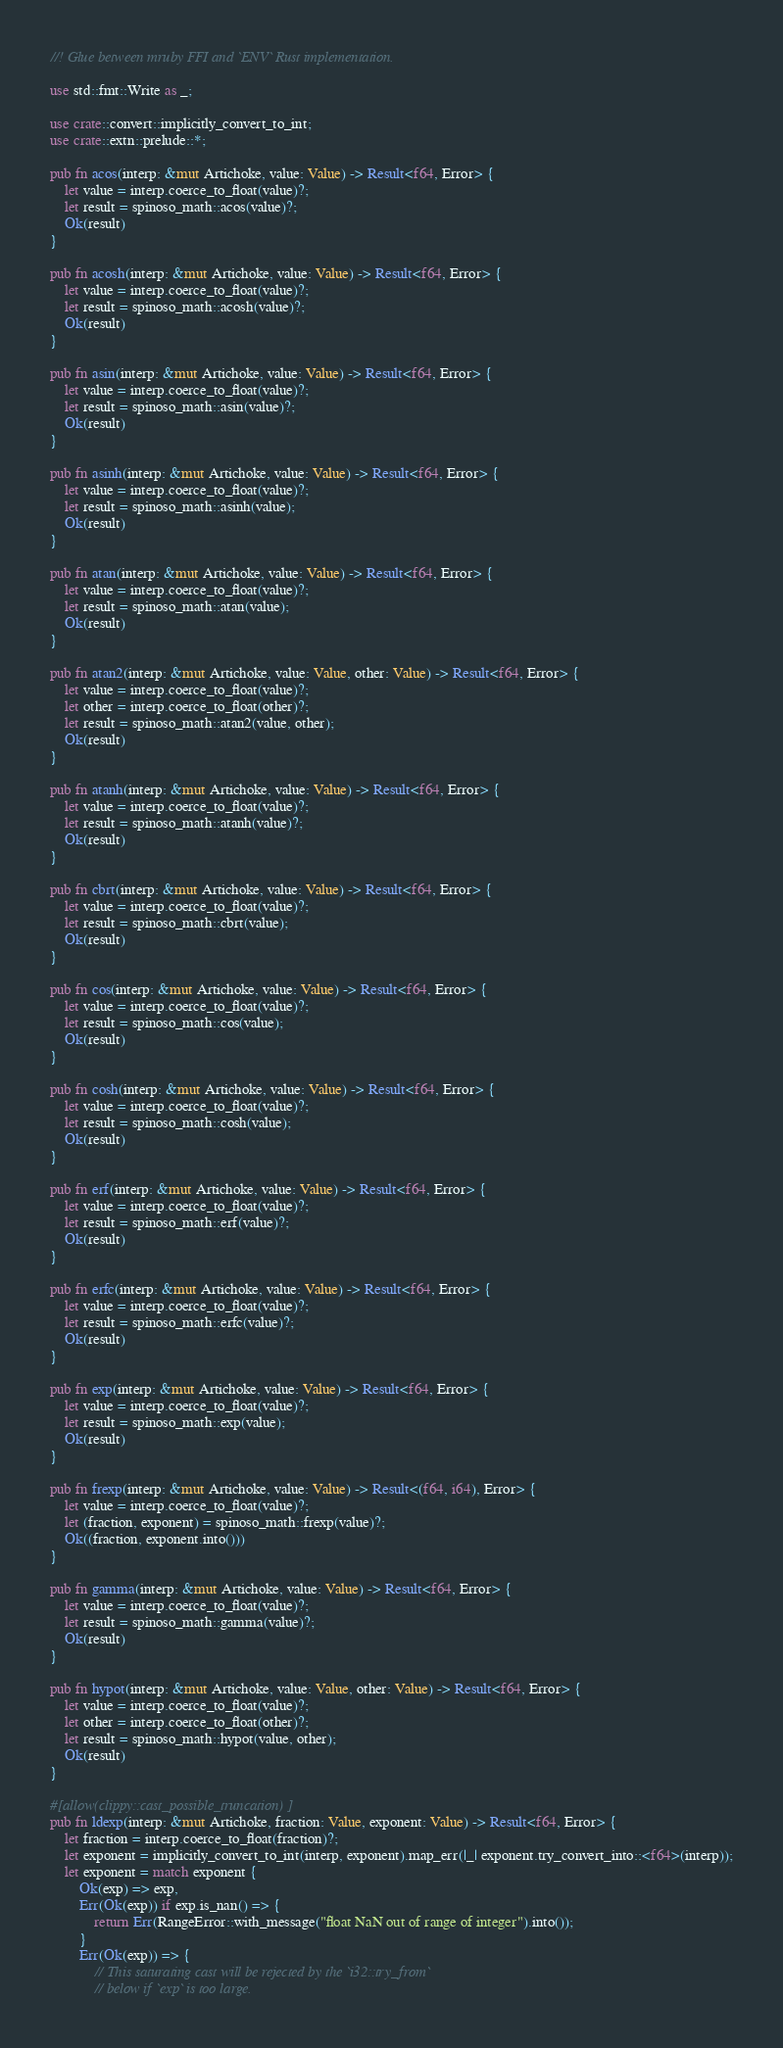Convert code to text. <code><loc_0><loc_0><loc_500><loc_500><_Rust_>//! Glue between mruby FFI and `ENV` Rust implementation.

use std::fmt::Write as _;

use crate::convert::implicitly_convert_to_int;
use crate::extn::prelude::*;

pub fn acos(interp: &mut Artichoke, value: Value) -> Result<f64, Error> {
    let value = interp.coerce_to_float(value)?;
    let result = spinoso_math::acos(value)?;
    Ok(result)
}

pub fn acosh(interp: &mut Artichoke, value: Value) -> Result<f64, Error> {
    let value = interp.coerce_to_float(value)?;
    let result = spinoso_math::acosh(value)?;
    Ok(result)
}

pub fn asin(interp: &mut Artichoke, value: Value) -> Result<f64, Error> {
    let value = interp.coerce_to_float(value)?;
    let result = spinoso_math::asin(value)?;
    Ok(result)
}

pub fn asinh(interp: &mut Artichoke, value: Value) -> Result<f64, Error> {
    let value = interp.coerce_to_float(value)?;
    let result = spinoso_math::asinh(value);
    Ok(result)
}

pub fn atan(interp: &mut Artichoke, value: Value) -> Result<f64, Error> {
    let value = interp.coerce_to_float(value)?;
    let result = spinoso_math::atan(value);
    Ok(result)
}

pub fn atan2(interp: &mut Artichoke, value: Value, other: Value) -> Result<f64, Error> {
    let value = interp.coerce_to_float(value)?;
    let other = interp.coerce_to_float(other)?;
    let result = spinoso_math::atan2(value, other);
    Ok(result)
}

pub fn atanh(interp: &mut Artichoke, value: Value) -> Result<f64, Error> {
    let value = interp.coerce_to_float(value)?;
    let result = spinoso_math::atanh(value)?;
    Ok(result)
}

pub fn cbrt(interp: &mut Artichoke, value: Value) -> Result<f64, Error> {
    let value = interp.coerce_to_float(value)?;
    let result = spinoso_math::cbrt(value);
    Ok(result)
}

pub fn cos(interp: &mut Artichoke, value: Value) -> Result<f64, Error> {
    let value = interp.coerce_to_float(value)?;
    let result = spinoso_math::cos(value);
    Ok(result)
}

pub fn cosh(interp: &mut Artichoke, value: Value) -> Result<f64, Error> {
    let value = interp.coerce_to_float(value)?;
    let result = spinoso_math::cosh(value);
    Ok(result)
}

pub fn erf(interp: &mut Artichoke, value: Value) -> Result<f64, Error> {
    let value = interp.coerce_to_float(value)?;
    let result = spinoso_math::erf(value)?;
    Ok(result)
}

pub fn erfc(interp: &mut Artichoke, value: Value) -> Result<f64, Error> {
    let value = interp.coerce_to_float(value)?;
    let result = spinoso_math::erfc(value)?;
    Ok(result)
}

pub fn exp(interp: &mut Artichoke, value: Value) -> Result<f64, Error> {
    let value = interp.coerce_to_float(value)?;
    let result = spinoso_math::exp(value);
    Ok(result)
}

pub fn frexp(interp: &mut Artichoke, value: Value) -> Result<(f64, i64), Error> {
    let value = interp.coerce_to_float(value)?;
    let (fraction, exponent) = spinoso_math::frexp(value)?;
    Ok((fraction, exponent.into()))
}

pub fn gamma(interp: &mut Artichoke, value: Value) -> Result<f64, Error> {
    let value = interp.coerce_to_float(value)?;
    let result = spinoso_math::gamma(value)?;
    Ok(result)
}

pub fn hypot(interp: &mut Artichoke, value: Value, other: Value) -> Result<f64, Error> {
    let value = interp.coerce_to_float(value)?;
    let other = interp.coerce_to_float(other)?;
    let result = spinoso_math::hypot(value, other);
    Ok(result)
}

#[allow(clippy::cast_possible_truncation)]
pub fn ldexp(interp: &mut Artichoke, fraction: Value, exponent: Value) -> Result<f64, Error> {
    let fraction = interp.coerce_to_float(fraction)?;
    let exponent = implicitly_convert_to_int(interp, exponent).map_err(|_| exponent.try_convert_into::<f64>(interp));
    let exponent = match exponent {
        Ok(exp) => exp,
        Err(Ok(exp)) if exp.is_nan() => {
            return Err(RangeError::with_message("float NaN out of range of integer").into());
        }
        Err(Ok(exp)) => {
            // This saturating cast will be rejected by the `i32::try_from`
            // below if `exp` is too large.</code> 